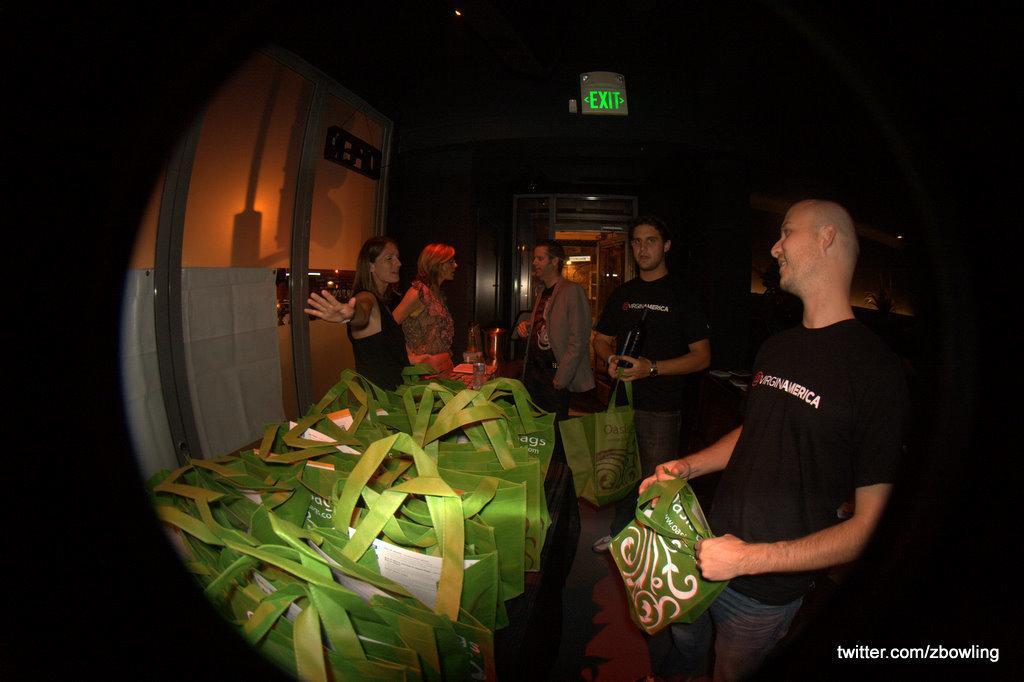Please provide a concise description of this image. In this image on the right there is a man, he wears a t shirt, trouser, he is holding a bag. In the middle there is a man, he wears a t shirt, trouser, he is holding a bag and there is a man, he wears a jacket, t shirt. On the left there are two women. In the middle there are many bags. In the background there are lights, exit board, wall. At the bottom there is text. 